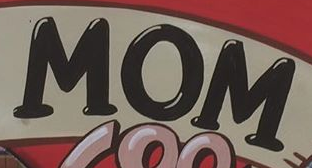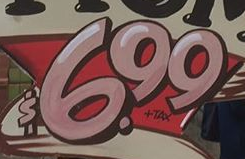What words are shown in these images in order, separated by a semicolon? MOM; $6.99 